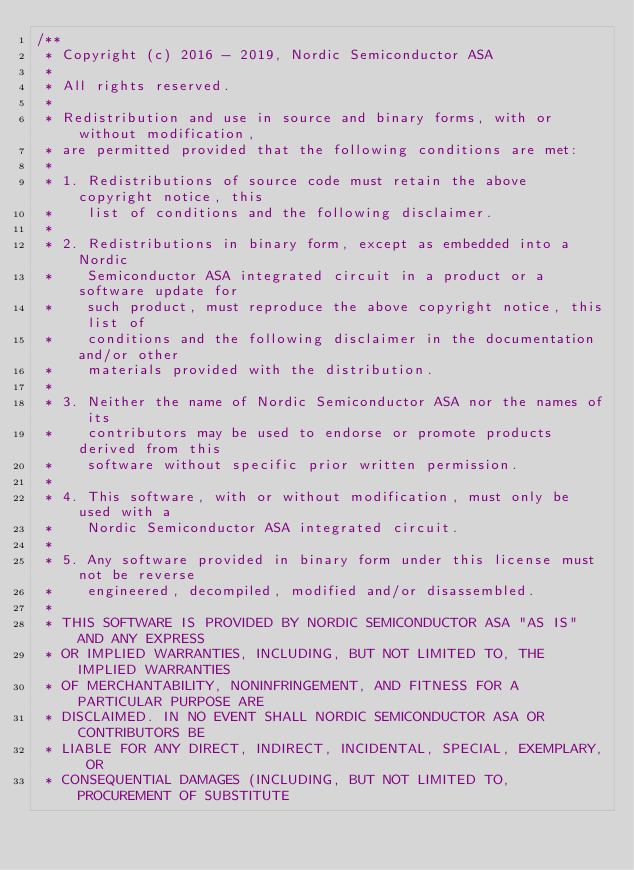Convert code to text. <code><loc_0><loc_0><loc_500><loc_500><_C_>/**
 * Copyright (c) 2016 - 2019, Nordic Semiconductor ASA
 *
 * All rights reserved.
 *
 * Redistribution and use in source and binary forms, with or without modification,
 * are permitted provided that the following conditions are met:
 *
 * 1. Redistributions of source code must retain the above copyright notice, this
 *    list of conditions and the following disclaimer.
 *
 * 2. Redistributions in binary form, except as embedded into a Nordic
 *    Semiconductor ASA integrated circuit in a product or a software update for
 *    such product, must reproduce the above copyright notice, this list of
 *    conditions and the following disclaimer in the documentation and/or other
 *    materials provided with the distribution.
 *
 * 3. Neither the name of Nordic Semiconductor ASA nor the names of its
 *    contributors may be used to endorse or promote products derived from this
 *    software without specific prior written permission.
 *
 * 4. This software, with or without modification, must only be used with a
 *    Nordic Semiconductor ASA integrated circuit.
 *
 * 5. Any software provided in binary form under this license must not be reverse
 *    engineered, decompiled, modified and/or disassembled.
 *
 * THIS SOFTWARE IS PROVIDED BY NORDIC SEMICONDUCTOR ASA "AS IS" AND ANY EXPRESS
 * OR IMPLIED WARRANTIES, INCLUDING, BUT NOT LIMITED TO, THE IMPLIED WARRANTIES
 * OF MERCHANTABILITY, NONINFRINGEMENT, AND FITNESS FOR A PARTICULAR PURPOSE ARE
 * DISCLAIMED. IN NO EVENT SHALL NORDIC SEMICONDUCTOR ASA OR CONTRIBUTORS BE
 * LIABLE FOR ANY DIRECT, INDIRECT, INCIDENTAL, SPECIAL, EXEMPLARY, OR
 * CONSEQUENTIAL DAMAGES (INCLUDING, BUT NOT LIMITED TO, PROCUREMENT OF SUBSTITUTE</code> 